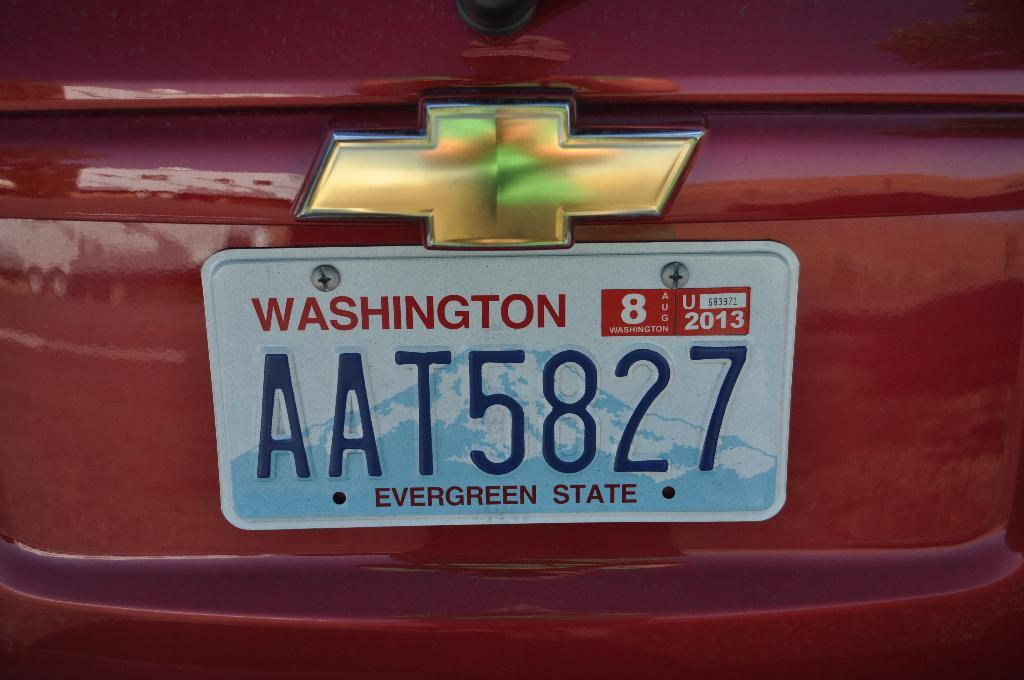Provide a one-sentence caption for the provided image. Red Chevy with the license plate "AAT5827" in the back. 